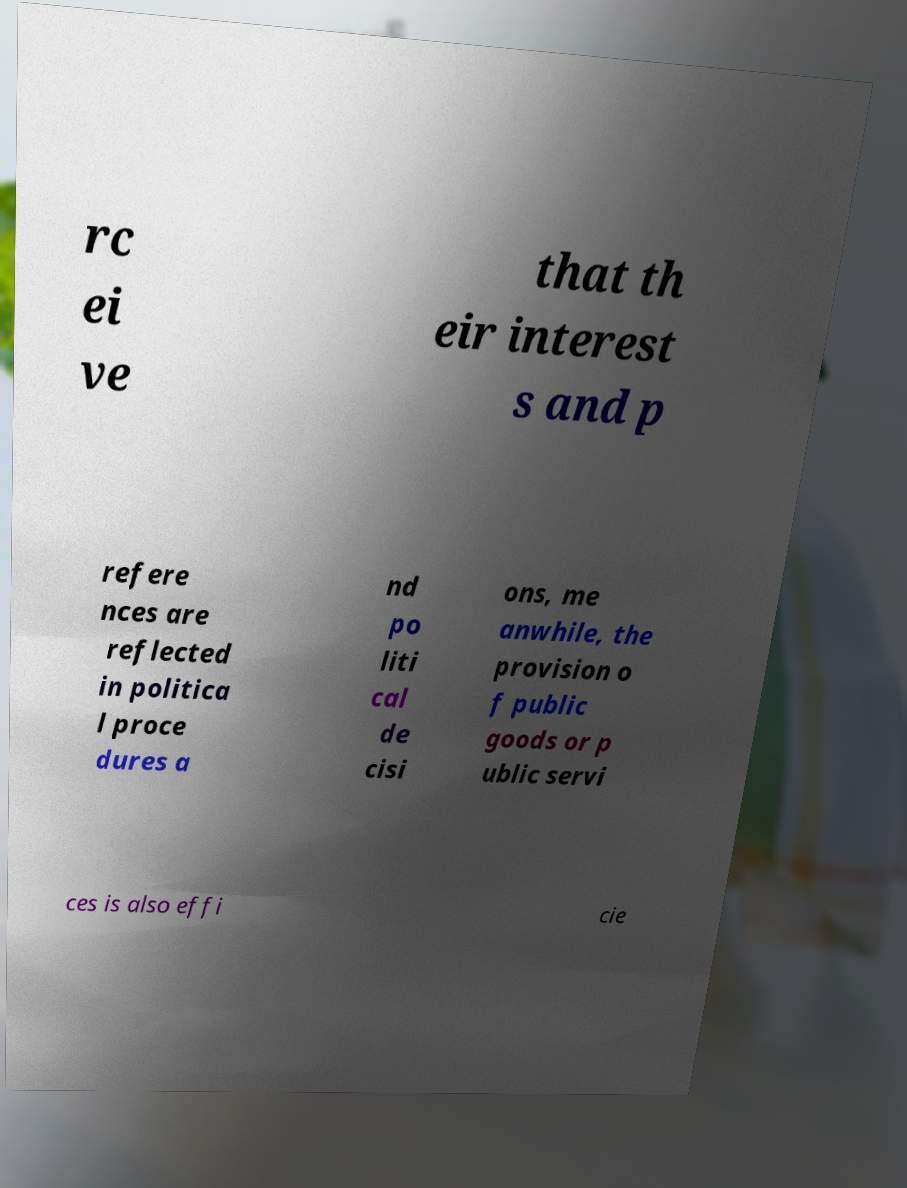There's text embedded in this image that I need extracted. Can you transcribe it verbatim? rc ei ve that th eir interest s and p refere nces are reflected in politica l proce dures a nd po liti cal de cisi ons, me anwhile, the provision o f public goods or p ublic servi ces is also effi cie 